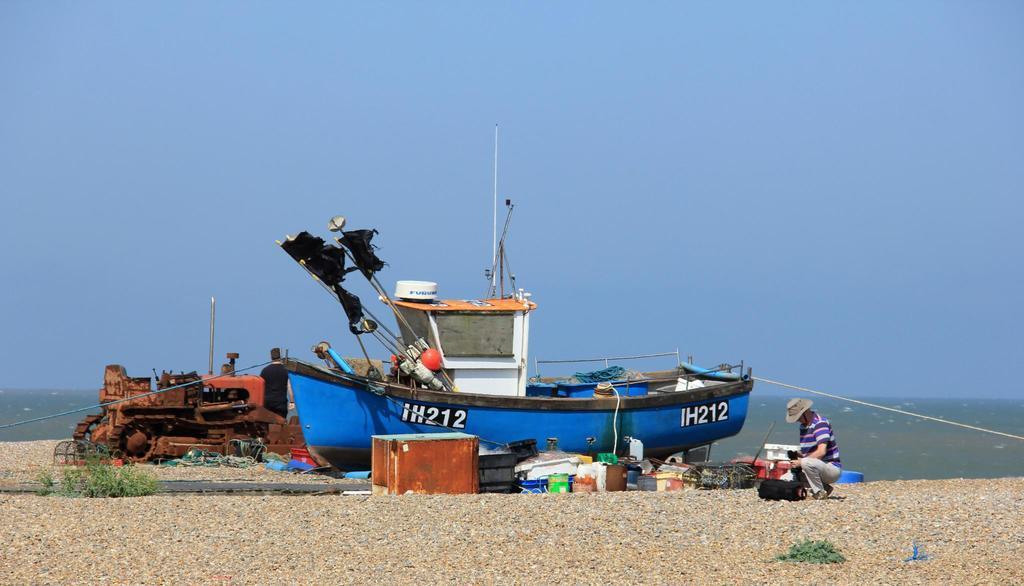How would you summarize this image in a sentence or two? In this image I can see a boat and few object inside. I can see a vehicle,two people,rope,brown box and few objects on the ground. I can see the water. The sky is in blue color. 